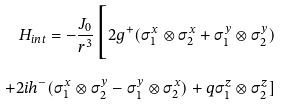Convert formula to latex. <formula><loc_0><loc_0><loc_500><loc_500>H _ { i n t } = - \frac { J _ { 0 } } { r ^ { 3 } } \Big [ 2 g ^ { + } ( \sigma _ { 1 } ^ { x } \otimes \sigma _ { 2 } ^ { x } + \sigma _ { 1 } ^ { y } \otimes \sigma _ { 2 } ^ { y } ) \\ + 2 i h ^ { - } ( \sigma _ { 1 } ^ { x } \otimes \sigma _ { 2 } ^ { y } - \sigma _ { 1 } ^ { y } \otimes \sigma _ { 2 } ^ { x } ) + q \sigma _ { 1 } ^ { z } \otimes \sigma _ { 2 } ^ { z } ]</formula> 